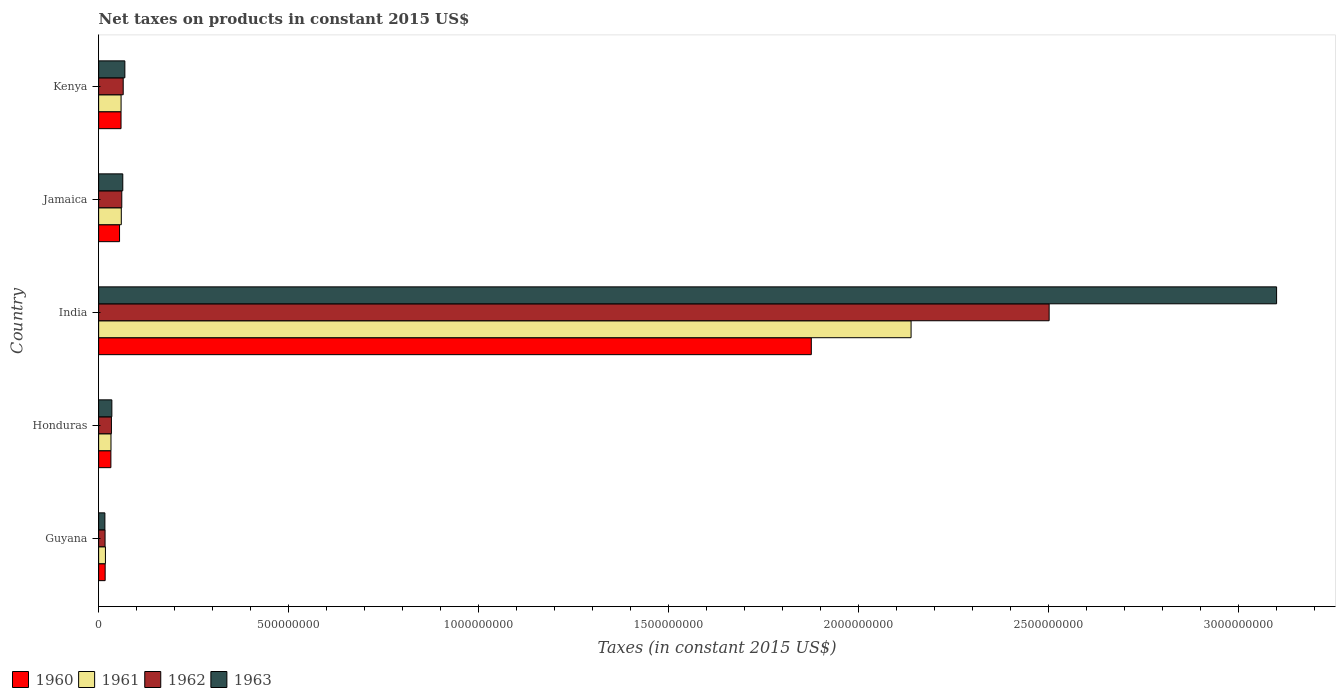How many different coloured bars are there?
Give a very brief answer. 4. Are the number of bars per tick equal to the number of legend labels?
Offer a very short reply. Yes. Are the number of bars on each tick of the Y-axis equal?
Offer a very short reply. Yes. How many bars are there on the 3rd tick from the top?
Ensure brevity in your answer.  4. How many bars are there on the 5th tick from the bottom?
Offer a very short reply. 4. What is the label of the 5th group of bars from the top?
Give a very brief answer. Guyana. What is the net taxes on products in 1963 in India?
Give a very brief answer. 3.10e+09. Across all countries, what is the maximum net taxes on products in 1962?
Your answer should be compact. 2.50e+09. Across all countries, what is the minimum net taxes on products in 1961?
Offer a very short reply. 1.79e+07. In which country was the net taxes on products in 1961 maximum?
Your answer should be very brief. India. In which country was the net taxes on products in 1963 minimum?
Make the answer very short. Guyana. What is the total net taxes on products in 1963 in the graph?
Your response must be concise. 3.28e+09. What is the difference between the net taxes on products in 1961 in India and that in Kenya?
Your answer should be very brief. 2.08e+09. What is the difference between the net taxes on products in 1960 in India and the net taxes on products in 1961 in Honduras?
Provide a short and direct response. 1.84e+09. What is the average net taxes on products in 1960 per country?
Provide a short and direct response. 4.08e+08. What is the difference between the net taxes on products in 1962 and net taxes on products in 1961 in Jamaica?
Your answer should be compact. 1.26e+06. In how many countries, is the net taxes on products in 1962 greater than 2900000000 US$?
Offer a terse response. 0. What is the ratio of the net taxes on products in 1960 in Honduras to that in Kenya?
Provide a succinct answer. 0.55. Is the net taxes on products in 1960 in India less than that in Kenya?
Your response must be concise. No. Is the difference between the net taxes on products in 1962 in India and Kenya greater than the difference between the net taxes on products in 1961 in India and Kenya?
Offer a very short reply. Yes. What is the difference between the highest and the second highest net taxes on products in 1960?
Your answer should be compact. 1.82e+09. What is the difference between the highest and the lowest net taxes on products in 1961?
Offer a terse response. 2.12e+09. In how many countries, is the net taxes on products in 1961 greater than the average net taxes on products in 1961 taken over all countries?
Provide a short and direct response. 1. What does the 1st bar from the top in India represents?
Your answer should be very brief. 1963. What does the 2nd bar from the bottom in Honduras represents?
Make the answer very short. 1961. How many bars are there?
Make the answer very short. 20. Does the graph contain any zero values?
Offer a terse response. No. Does the graph contain grids?
Your answer should be very brief. No. How many legend labels are there?
Ensure brevity in your answer.  4. What is the title of the graph?
Offer a terse response. Net taxes on products in constant 2015 US$. What is the label or title of the X-axis?
Ensure brevity in your answer.  Taxes (in constant 2015 US$). What is the Taxes (in constant 2015 US$) in 1960 in Guyana?
Provide a short and direct response. 1.71e+07. What is the Taxes (in constant 2015 US$) in 1961 in Guyana?
Your response must be concise. 1.79e+07. What is the Taxes (in constant 2015 US$) of 1962 in Guyana?
Make the answer very short. 1.69e+07. What is the Taxes (in constant 2015 US$) of 1963 in Guyana?
Make the answer very short. 1.64e+07. What is the Taxes (in constant 2015 US$) of 1960 in Honduras?
Provide a short and direct response. 3.22e+07. What is the Taxes (in constant 2015 US$) of 1961 in Honduras?
Your answer should be compact. 3.25e+07. What is the Taxes (in constant 2015 US$) in 1962 in Honduras?
Keep it short and to the point. 3.36e+07. What is the Taxes (in constant 2015 US$) of 1963 in Honduras?
Offer a very short reply. 3.48e+07. What is the Taxes (in constant 2015 US$) of 1960 in India?
Keep it short and to the point. 1.88e+09. What is the Taxes (in constant 2015 US$) of 1961 in India?
Provide a short and direct response. 2.14e+09. What is the Taxes (in constant 2015 US$) of 1962 in India?
Your answer should be compact. 2.50e+09. What is the Taxes (in constant 2015 US$) in 1963 in India?
Offer a very short reply. 3.10e+09. What is the Taxes (in constant 2015 US$) in 1960 in Jamaica?
Provide a succinct answer. 5.50e+07. What is the Taxes (in constant 2015 US$) of 1961 in Jamaica?
Keep it short and to the point. 5.96e+07. What is the Taxes (in constant 2015 US$) of 1962 in Jamaica?
Keep it short and to the point. 6.09e+07. What is the Taxes (in constant 2015 US$) of 1963 in Jamaica?
Provide a succinct answer. 6.36e+07. What is the Taxes (in constant 2015 US$) in 1960 in Kenya?
Keep it short and to the point. 5.89e+07. What is the Taxes (in constant 2015 US$) of 1961 in Kenya?
Your response must be concise. 5.91e+07. What is the Taxes (in constant 2015 US$) in 1962 in Kenya?
Offer a very short reply. 6.47e+07. What is the Taxes (in constant 2015 US$) of 1963 in Kenya?
Give a very brief answer. 6.90e+07. Across all countries, what is the maximum Taxes (in constant 2015 US$) of 1960?
Your response must be concise. 1.88e+09. Across all countries, what is the maximum Taxes (in constant 2015 US$) of 1961?
Offer a terse response. 2.14e+09. Across all countries, what is the maximum Taxes (in constant 2015 US$) in 1962?
Your answer should be compact. 2.50e+09. Across all countries, what is the maximum Taxes (in constant 2015 US$) of 1963?
Your answer should be compact. 3.10e+09. Across all countries, what is the minimum Taxes (in constant 2015 US$) of 1960?
Offer a very short reply. 1.71e+07. Across all countries, what is the minimum Taxes (in constant 2015 US$) in 1961?
Your answer should be very brief. 1.79e+07. Across all countries, what is the minimum Taxes (in constant 2015 US$) of 1962?
Make the answer very short. 1.69e+07. Across all countries, what is the minimum Taxes (in constant 2015 US$) in 1963?
Make the answer very short. 1.64e+07. What is the total Taxes (in constant 2015 US$) of 1960 in the graph?
Ensure brevity in your answer.  2.04e+09. What is the total Taxes (in constant 2015 US$) in 1961 in the graph?
Make the answer very short. 2.31e+09. What is the total Taxes (in constant 2015 US$) in 1962 in the graph?
Provide a short and direct response. 2.68e+09. What is the total Taxes (in constant 2015 US$) in 1963 in the graph?
Offer a terse response. 3.28e+09. What is the difference between the Taxes (in constant 2015 US$) of 1960 in Guyana and that in Honduras?
Keep it short and to the point. -1.51e+07. What is the difference between the Taxes (in constant 2015 US$) of 1961 in Guyana and that in Honduras?
Give a very brief answer. -1.46e+07. What is the difference between the Taxes (in constant 2015 US$) in 1962 in Guyana and that in Honduras?
Your response must be concise. -1.67e+07. What is the difference between the Taxes (in constant 2015 US$) of 1963 in Guyana and that in Honduras?
Offer a very short reply. -1.84e+07. What is the difference between the Taxes (in constant 2015 US$) of 1960 in Guyana and that in India?
Your response must be concise. -1.86e+09. What is the difference between the Taxes (in constant 2015 US$) in 1961 in Guyana and that in India?
Provide a succinct answer. -2.12e+09. What is the difference between the Taxes (in constant 2015 US$) of 1962 in Guyana and that in India?
Your answer should be very brief. -2.48e+09. What is the difference between the Taxes (in constant 2015 US$) of 1963 in Guyana and that in India?
Provide a succinct answer. -3.08e+09. What is the difference between the Taxes (in constant 2015 US$) in 1960 in Guyana and that in Jamaica?
Your response must be concise. -3.79e+07. What is the difference between the Taxes (in constant 2015 US$) in 1961 in Guyana and that in Jamaica?
Your answer should be very brief. -4.17e+07. What is the difference between the Taxes (in constant 2015 US$) in 1962 in Guyana and that in Jamaica?
Your answer should be compact. -4.40e+07. What is the difference between the Taxes (in constant 2015 US$) of 1963 in Guyana and that in Jamaica?
Provide a succinct answer. -4.71e+07. What is the difference between the Taxes (in constant 2015 US$) in 1960 in Guyana and that in Kenya?
Give a very brief answer. -4.18e+07. What is the difference between the Taxes (in constant 2015 US$) of 1961 in Guyana and that in Kenya?
Your answer should be compact. -4.12e+07. What is the difference between the Taxes (in constant 2015 US$) in 1962 in Guyana and that in Kenya?
Offer a terse response. -4.77e+07. What is the difference between the Taxes (in constant 2015 US$) of 1963 in Guyana and that in Kenya?
Give a very brief answer. -5.26e+07. What is the difference between the Taxes (in constant 2015 US$) of 1960 in Honduras and that in India?
Ensure brevity in your answer.  -1.84e+09. What is the difference between the Taxes (in constant 2015 US$) in 1961 in Honduras and that in India?
Offer a very short reply. -2.11e+09. What is the difference between the Taxes (in constant 2015 US$) in 1962 in Honduras and that in India?
Your answer should be compact. -2.47e+09. What is the difference between the Taxes (in constant 2015 US$) in 1963 in Honduras and that in India?
Ensure brevity in your answer.  -3.06e+09. What is the difference between the Taxes (in constant 2015 US$) of 1960 in Honduras and that in Jamaica?
Provide a succinct answer. -2.28e+07. What is the difference between the Taxes (in constant 2015 US$) in 1961 in Honduras and that in Jamaica?
Give a very brief answer. -2.71e+07. What is the difference between the Taxes (in constant 2015 US$) in 1962 in Honduras and that in Jamaica?
Make the answer very short. -2.72e+07. What is the difference between the Taxes (in constant 2015 US$) of 1963 in Honduras and that in Jamaica?
Offer a terse response. -2.88e+07. What is the difference between the Taxes (in constant 2015 US$) in 1960 in Honduras and that in Kenya?
Your response must be concise. -2.67e+07. What is the difference between the Taxes (in constant 2015 US$) of 1961 in Honduras and that in Kenya?
Your answer should be compact. -2.66e+07. What is the difference between the Taxes (in constant 2015 US$) of 1962 in Honduras and that in Kenya?
Offer a very short reply. -3.10e+07. What is the difference between the Taxes (in constant 2015 US$) in 1963 in Honduras and that in Kenya?
Keep it short and to the point. -3.42e+07. What is the difference between the Taxes (in constant 2015 US$) of 1960 in India and that in Jamaica?
Provide a succinct answer. 1.82e+09. What is the difference between the Taxes (in constant 2015 US$) of 1961 in India and that in Jamaica?
Provide a succinct answer. 2.08e+09. What is the difference between the Taxes (in constant 2015 US$) in 1962 in India and that in Jamaica?
Offer a terse response. 2.44e+09. What is the difference between the Taxes (in constant 2015 US$) in 1963 in India and that in Jamaica?
Your answer should be compact. 3.04e+09. What is the difference between the Taxes (in constant 2015 US$) of 1960 in India and that in Kenya?
Offer a very short reply. 1.82e+09. What is the difference between the Taxes (in constant 2015 US$) in 1961 in India and that in Kenya?
Your answer should be compact. 2.08e+09. What is the difference between the Taxes (in constant 2015 US$) in 1962 in India and that in Kenya?
Provide a succinct answer. 2.44e+09. What is the difference between the Taxes (in constant 2015 US$) of 1963 in India and that in Kenya?
Keep it short and to the point. 3.03e+09. What is the difference between the Taxes (in constant 2015 US$) of 1960 in Jamaica and that in Kenya?
Offer a very short reply. -3.91e+06. What is the difference between the Taxes (in constant 2015 US$) in 1961 in Jamaica and that in Kenya?
Ensure brevity in your answer.  5.74e+05. What is the difference between the Taxes (in constant 2015 US$) of 1962 in Jamaica and that in Kenya?
Offer a very short reply. -3.75e+06. What is the difference between the Taxes (in constant 2015 US$) in 1963 in Jamaica and that in Kenya?
Provide a succinct answer. -5.46e+06. What is the difference between the Taxes (in constant 2015 US$) in 1960 in Guyana and the Taxes (in constant 2015 US$) in 1961 in Honduras?
Keep it short and to the point. -1.54e+07. What is the difference between the Taxes (in constant 2015 US$) in 1960 in Guyana and the Taxes (in constant 2015 US$) in 1962 in Honduras?
Provide a short and direct response. -1.65e+07. What is the difference between the Taxes (in constant 2015 US$) of 1960 in Guyana and the Taxes (in constant 2015 US$) of 1963 in Honduras?
Your answer should be compact. -1.77e+07. What is the difference between the Taxes (in constant 2015 US$) in 1961 in Guyana and the Taxes (in constant 2015 US$) in 1962 in Honduras?
Provide a succinct answer. -1.57e+07. What is the difference between the Taxes (in constant 2015 US$) of 1961 in Guyana and the Taxes (in constant 2015 US$) of 1963 in Honduras?
Your answer should be compact. -1.69e+07. What is the difference between the Taxes (in constant 2015 US$) in 1962 in Guyana and the Taxes (in constant 2015 US$) in 1963 in Honduras?
Provide a succinct answer. -1.79e+07. What is the difference between the Taxes (in constant 2015 US$) of 1960 in Guyana and the Taxes (in constant 2015 US$) of 1961 in India?
Your response must be concise. -2.12e+09. What is the difference between the Taxes (in constant 2015 US$) in 1960 in Guyana and the Taxes (in constant 2015 US$) in 1962 in India?
Provide a succinct answer. -2.48e+09. What is the difference between the Taxes (in constant 2015 US$) in 1960 in Guyana and the Taxes (in constant 2015 US$) in 1963 in India?
Ensure brevity in your answer.  -3.08e+09. What is the difference between the Taxes (in constant 2015 US$) of 1961 in Guyana and the Taxes (in constant 2015 US$) of 1962 in India?
Keep it short and to the point. -2.48e+09. What is the difference between the Taxes (in constant 2015 US$) of 1961 in Guyana and the Taxes (in constant 2015 US$) of 1963 in India?
Ensure brevity in your answer.  -3.08e+09. What is the difference between the Taxes (in constant 2015 US$) in 1962 in Guyana and the Taxes (in constant 2015 US$) in 1963 in India?
Your answer should be compact. -3.08e+09. What is the difference between the Taxes (in constant 2015 US$) of 1960 in Guyana and the Taxes (in constant 2015 US$) of 1961 in Jamaica?
Ensure brevity in your answer.  -4.25e+07. What is the difference between the Taxes (in constant 2015 US$) of 1960 in Guyana and the Taxes (in constant 2015 US$) of 1962 in Jamaica?
Ensure brevity in your answer.  -4.38e+07. What is the difference between the Taxes (in constant 2015 US$) in 1960 in Guyana and the Taxes (in constant 2015 US$) in 1963 in Jamaica?
Provide a short and direct response. -4.64e+07. What is the difference between the Taxes (in constant 2015 US$) in 1961 in Guyana and the Taxes (in constant 2015 US$) in 1962 in Jamaica?
Ensure brevity in your answer.  -4.30e+07. What is the difference between the Taxes (in constant 2015 US$) of 1961 in Guyana and the Taxes (in constant 2015 US$) of 1963 in Jamaica?
Your answer should be compact. -4.57e+07. What is the difference between the Taxes (in constant 2015 US$) in 1962 in Guyana and the Taxes (in constant 2015 US$) in 1963 in Jamaica?
Your response must be concise. -4.66e+07. What is the difference between the Taxes (in constant 2015 US$) of 1960 in Guyana and the Taxes (in constant 2015 US$) of 1961 in Kenya?
Give a very brief answer. -4.19e+07. What is the difference between the Taxes (in constant 2015 US$) in 1960 in Guyana and the Taxes (in constant 2015 US$) in 1962 in Kenya?
Provide a short and direct response. -4.75e+07. What is the difference between the Taxes (in constant 2015 US$) of 1960 in Guyana and the Taxes (in constant 2015 US$) of 1963 in Kenya?
Give a very brief answer. -5.19e+07. What is the difference between the Taxes (in constant 2015 US$) in 1961 in Guyana and the Taxes (in constant 2015 US$) in 1962 in Kenya?
Offer a terse response. -4.67e+07. What is the difference between the Taxes (in constant 2015 US$) in 1961 in Guyana and the Taxes (in constant 2015 US$) in 1963 in Kenya?
Offer a terse response. -5.11e+07. What is the difference between the Taxes (in constant 2015 US$) in 1962 in Guyana and the Taxes (in constant 2015 US$) in 1963 in Kenya?
Your answer should be compact. -5.21e+07. What is the difference between the Taxes (in constant 2015 US$) of 1960 in Honduras and the Taxes (in constant 2015 US$) of 1961 in India?
Offer a very short reply. -2.11e+09. What is the difference between the Taxes (in constant 2015 US$) in 1960 in Honduras and the Taxes (in constant 2015 US$) in 1962 in India?
Keep it short and to the point. -2.47e+09. What is the difference between the Taxes (in constant 2015 US$) in 1960 in Honduras and the Taxes (in constant 2015 US$) in 1963 in India?
Your answer should be very brief. -3.07e+09. What is the difference between the Taxes (in constant 2015 US$) of 1961 in Honduras and the Taxes (in constant 2015 US$) of 1962 in India?
Keep it short and to the point. -2.47e+09. What is the difference between the Taxes (in constant 2015 US$) of 1961 in Honduras and the Taxes (in constant 2015 US$) of 1963 in India?
Make the answer very short. -3.07e+09. What is the difference between the Taxes (in constant 2015 US$) of 1962 in Honduras and the Taxes (in constant 2015 US$) of 1963 in India?
Offer a very short reply. -3.07e+09. What is the difference between the Taxes (in constant 2015 US$) in 1960 in Honduras and the Taxes (in constant 2015 US$) in 1961 in Jamaica?
Provide a short and direct response. -2.74e+07. What is the difference between the Taxes (in constant 2015 US$) of 1960 in Honduras and the Taxes (in constant 2015 US$) of 1962 in Jamaica?
Offer a very short reply. -2.86e+07. What is the difference between the Taxes (in constant 2015 US$) in 1960 in Honduras and the Taxes (in constant 2015 US$) in 1963 in Jamaica?
Keep it short and to the point. -3.13e+07. What is the difference between the Taxes (in constant 2015 US$) in 1961 in Honduras and the Taxes (in constant 2015 US$) in 1962 in Jamaica?
Your answer should be compact. -2.84e+07. What is the difference between the Taxes (in constant 2015 US$) of 1961 in Honduras and the Taxes (in constant 2015 US$) of 1963 in Jamaica?
Keep it short and to the point. -3.11e+07. What is the difference between the Taxes (in constant 2015 US$) in 1962 in Honduras and the Taxes (in constant 2015 US$) in 1963 in Jamaica?
Make the answer very short. -2.99e+07. What is the difference between the Taxes (in constant 2015 US$) of 1960 in Honduras and the Taxes (in constant 2015 US$) of 1961 in Kenya?
Give a very brief answer. -2.68e+07. What is the difference between the Taxes (in constant 2015 US$) in 1960 in Honduras and the Taxes (in constant 2015 US$) in 1962 in Kenya?
Your answer should be very brief. -3.24e+07. What is the difference between the Taxes (in constant 2015 US$) of 1960 in Honduras and the Taxes (in constant 2015 US$) of 1963 in Kenya?
Keep it short and to the point. -3.68e+07. What is the difference between the Taxes (in constant 2015 US$) in 1961 in Honduras and the Taxes (in constant 2015 US$) in 1962 in Kenya?
Your response must be concise. -3.22e+07. What is the difference between the Taxes (in constant 2015 US$) of 1961 in Honduras and the Taxes (in constant 2015 US$) of 1963 in Kenya?
Offer a terse response. -3.65e+07. What is the difference between the Taxes (in constant 2015 US$) in 1962 in Honduras and the Taxes (in constant 2015 US$) in 1963 in Kenya?
Provide a succinct answer. -3.54e+07. What is the difference between the Taxes (in constant 2015 US$) in 1960 in India and the Taxes (in constant 2015 US$) in 1961 in Jamaica?
Provide a short and direct response. 1.82e+09. What is the difference between the Taxes (in constant 2015 US$) of 1960 in India and the Taxes (in constant 2015 US$) of 1962 in Jamaica?
Your answer should be compact. 1.81e+09. What is the difference between the Taxes (in constant 2015 US$) of 1960 in India and the Taxes (in constant 2015 US$) of 1963 in Jamaica?
Give a very brief answer. 1.81e+09. What is the difference between the Taxes (in constant 2015 US$) in 1961 in India and the Taxes (in constant 2015 US$) in 1962 in Jamaica?
Offer a very short reply. 2.08e+09. What is the difference between the Taxes (in constant 2015 US$) of 1961 in India and the Taxes (in constant 2015 US$) of 1963 in Jamaica?
Give a very brief answer. 2.07e+09. What is the difference between the Taxes (in constant 2015 US$) of 1962 in India and the Taxes (in constant 2015 US$) of 1963 in Jamaica?
Offer a terse response. 2.44e+09. What is the difference between the Taxes (in constant 2015 US$) in 1960 in India and the Taxes (in constant 2015 US$) in 1961 in Kenya?
Make the answer very short. 1.82e+09. What is the difference between the Taxes (in constant 2015 US$) of 1960 in India and the Taxes (in constant 2015 US$) of 1962 in Kenya?
Offer a terse response. 1.81e+09. What is the difference between the Taxes (in constant 2015 US$) in 1960 in India and the Taxes (in constant 2015 US$) in 1963 in Kenya?
Your answer should be compact. 1.81e+09. What is the difference between the Taxes (in constant 2015 US$) of 1961 in India and the Taxes (in constant 2015 US$) of 1962 in Kenya?
Ensure brevity in your answer.  2.07e+09. What is the difference between the Taxes (in constant 2015 US$) in 1961 in India and the Taxes (in constant 2015 US$) in 1963 in Kenya?
Ensure brevity in your answer.  2.07e+09. What is the difference between the Taxes (in constant 2015 US$) in 1962 in India and the Taxes (in constant 2015 US$) in 1963 in Kenya?
Offer a terse response. 2.43e+09. What is the difference between the Taxes (in constant 2015 US$) in 1960 in Jamaica and the Taxes (in constant 2015 US$) in 1961 in Kenya?
Your answer should be compact. -4.05e+06. What is the difference between the Taxes (in constant 2015 US$) in 1960 in Jamaica and the Taxes (in constant 2015 US$) in 1962 in Kenya?
Your answer should be very brief. -9.63e+06. What is the difference between the Taxes (in constant 2015 US$) in 1960 in Jamaica and the Taxes (in constant 2015 US$) in 1963 in Kenya?
Your response must be concise. -1.40e+07. What is the difference between the Taxes (in constant 2015 US$) of 1961 in Jamaica and the Taxes (in constant 2015 US$) of 1962 in Kenya?
Your response must be concise. -5.01e+06. What is the difference between the Taxes (in constant 2015 US$) of 1961 in Jamaica and the Taxes (in constant 2015 US$) of 1963 in Kenya?
Offer a terse response. -9.38e+06. What is the difference between the Taxes (in constant 2015 US$) in 1962 in Jamaica and the Taxes (in constant 2015 US$) in 1963 in Kenya?
Your answer should be compact. -8.12e+06. What is the average Taxes (in constant 2015 US$) in 1960 per country?
Provide a succinct answer. 4.08e+08. What is the average Taxes (in constant 2015 US$) of 1961 per country?
Offer a very short reply. 4.61e+08. What is the average Taxes (in constant 2015 US$) in 1962 per country?
Offer a very short reply. 5.35e+08. What is the average Taxes (in constant 2015 US$) in 1963 per country?
Offer a very short reply. 6.57e+08. What is the difference between the Taxes (in constant 2015 US$) of 1960 and Taxes (in constant 2015 US$) of 1961 in Guyana?
Ensure brevity in your answer.  -7.58e+05. What is the difference between the Taxes (in constant 2015 US$) of 1960 and Taxes (in constant 2015 US$) of 1962 in Guyana?
Your answer should be very brief. 2.33e+05. What is the difference between the Taxes (in constant 2015 US$) of 1960 and Taxes (in constant 2015 US$) of 1963 in Guyana?
Your response must be concise. 7.00e+05. What is the difference between the Taxes (in constant 2015 US$) of 1961 and Taxes (in constant 2015 US$) of 1962 in Guyana?
Make the answer very short. 9.92e+05. What is the difference between the Taxes (in constant 2015 US$) in 1961 and Taxes (in constant 2015 US$) in 1963 in Guyana?
Provide a succinct answer. 1.46e+06. What is the difference between the Taxes (in constant 2015 US$) of 1962 and Taxes (in constant 2015 US$) of 1963 in Guyana?
Offer a terse response. 4.67e+05. What is the difference between the Taxes (in constant 2015 US$) in 1960 and Taxes (in constant 2015 US$) in 1961 in Honduras?
Your answer should be very brief. -2.50e+05. What is the difference between the Taxes (in constant 2015 US$) in 1960 and Taxes (in constant 2015 US$) in 1962 in Honduras?
Offer a very short reply. -1.40e+06. What is the difference between the Taxes (in constant 2015 US$) of 1960 and Taxes (in constant 2015 US$) of 1963 in Honduras?
Offer a terse response. -2.55e+06. What is the difference between the Taxes (in constant 2015 US$) of 1961 and Taxes (in constant 2015 US$) of 1962 in Honduras?
Ensure brevity in your answer.  -1.15e+06. What is the difference between the Taxes (in constant 2015 US$) in 1961 and Taxes (in constant 2015 US$) in 1963 in Honduras?
Give a very brief answer. -2.30e+06. What is the difference between the Taxes (in constant 2015 US$) in 1962 and Taxes (in constant 2015 US$) in 1963 in Honduras?
Your response must be concise. -1.15e+06. What is the difference between the Taxes (in constant 2015 US$) in 1960 and Taxes (in constant 2015 US$) in 1961 in India?
Offer a terse response. -2.63e+08. What is the difference between the Taxes (in constant 2015 US$) in 1960 and Taxes (in constant 2015 US$) in 1962 in India?
Give a very brief answer. -6.26e+08. What is the difference between the Taxes (in constant 2015 US$) in 1960 and Taxes (in constant 2015 US$) in 1963 in India?
Keep it short and to the point. -1.22e+09. What is the difference between the Taxes (in constant 2015 US$) in 1961 and Taxes (in constant 2015 US$) in 1962 in India?
Provide a short and direct response. -3.63e+08. What is the difference between the Taxes (in constant 2015 US$) in 1961 and Taxes (in constant 2015 US$) in 1963 in India?
Provide a succinct answer. -9.62e+08. What is the difference between the Taxes (in constant 2015 US$) of 1962 and Taxes (in constant 2015 US$) of 1963 in India?
Give a very brief answer. -5.99e+08. What is the difference between the Taxes (in constant 2015 US$) of 1960 and Taxes (in constant 2015 US$) of 1961 in Jamaica?
Provide a succinct answer. -4.62e+06. What is the difference between the Taxes (in constant 2015 US$) of 1960 and Taxes (in constant 2015 US$) of 1962 in Jamaica?
Your answer should be very brief. -5.88e+06. What is the difference between the Taxes (in constant 2015 US$) in 1960 and Taxes (in constant 2015 US$) in 1963 in Jamaica?
Your answer should be compact. -8.54e+06. What is the difference between the Taxes (in constant 2015 US$) of 1961 and Taxes (in constant 2015 US$) of 1962 in Jamaica?
Provide a short and direct response. -1.26e+06. What is the difference between the Taxes (in constant 2015 US$) of 1961 and Taxes (in constant 2015 US$) of 1963 in Jamaica?
Your response must be concise. -3.92e+06. What is the difference between the Taxes (in constant 2015 US$) of 1962 and Taxes (in constant 2015 US$) of 1963 in Jamaica?
Offer a very short reply. -2.66e+06. What is the difference between the Taxes (in constant 2015 US$) of 1960 and Taxes (in constant 2015 US$) of 1961 in Kenya?
Your answer should be compact. -1.40e+05. What is the difference between the Taxes (in constant 2015 US$) of 1960 and Taxes (in constant 2015 US$) of 1962 in Kenya?
Offer a very short reply. -5.73e+06. What is the difference between the Taxes (in constant 2015 US$) in 1960 and Taxes (in constant 2015 US$) in 1963 in Kenya?
Offer a terse response. -1.01e+07. What is the difference between the Taxes (in constant 2015 US$) in 1961 and Taxes (in constant 2015 US$) in 1962 in Kenya?
Keep it short and to the point. -5.59e+06. What is the difference between the Taxes (in constant 2015 US$) in 1961 and Taxes (in constant 2015 US$) in 1963 in Kenya?
Give a very brief answer. -9.95e+06. What is the difference between the Taxes (in constant 2015 US$) in 1962 and Taxes (in constant 2015 US$) in 1963 in Kenya?
Give a very brief answer. -4.37e+06. What is the ratio of the Taxes (in constant 2015 US$) in 1960 in Guyana to that in Honduras?
Give a very brief answer. 0.53. What is the ratio of the Taxes (in constant 2015 US$) of 1961 in Guyana to that in Honduras?
Give a very brief answer. 0.55. What is the ratio of the Taxes (in constant 2015 US$) of 1962 in Guyana to that in Honduras?
Make the answer very short. 0.5. What is the ratio of the Taxes (in constant 2015 US$) in 1963 in Guyana to that in Honduras?
Ensure brevity in your answer.  0.47. What is the ratio of the Taxes (in constant 2015 US$) of 1960 in Guyana to that in India?
Offer a terse response. 0.01. What is the ratio of the Taxes (in constant 2015 US$) in 1961 in Guyana to that in India?
Your answer should be very brief. 0.01. What is the ratio of the Taxes (in constant 2015 US$) in 1962 in Guyana to that in India?
Offer a very short reply. 0.01. What is the ratio of the Taxes (in constant 2015 US$) in 1963 in Guyana to that in India?
Your answer should be very brief. 0.01. What is the ratio of the Taxes (in constant 2015 US$) in 1960 in Guyana to that in Jamaica?
Keep it short and to the point. 0.31. What is the ratio of the Taxes (in constant 2015 US$) in 1961 in Guyana to that in Jamaica?
Give a very brief answer. 0.3. What is the ratio of the Taxes (in constant 2015 US$) in 1962 in Guyana to that in Jamaica?
Offer a terse response. 0.28. What is the ratio of the Taxes (in constant 2015 US$) in 1963 in Guyana to that in Jamaica?
Provide a short and direct response. 0.26. What is the ratio of the Taxes (in constant 2015 US$) in 1960 in Guyana to that in Kenya?
Your answer should be compact. 0.29. What is the ratio of the Taxes (in constant 2015 US$) in 1961 in Guyana to that in Kenya?
Make the answer very short. 0.3. What is the ratio of the Taxes (in constant 2015 US$) of 1962 in Guyana to that in Kenya?
Provide a succinct answer. 0.26. What is the ratio of the Taxes (in constant 2015 US$) of 1963 in Guyana to that in Kenya?
Your answer should be compact. 0.24. What is the ratio of the Taxes (in constant 2015 US$) of 1960 in Honduras to that in India?
Your response must be concise. 0.02. What is the ratio of the Taxes (in constant 2015 US$) in 1961 in Honduras to that in India?
Make the answer very short. 0.02. What is the ratio of the Taxes (in constant 2015 US$) in 1962 in Honduras to that in India?
Provide a succinct answer. 0.01. What is the ratio of the Taxes (in constant 2015 US$) in 1963 in Honduras to that in India?
Make the answer very short. 0.01. What is the ratio of the Taxes (in constant 2015 US$) of 1960 in Honduras to that in Jamaica?
Ensure brevity in your answer.  0.59. What is the ratio of the Taxes (in constant 2015 US$) of 1961 in Honduras to that in Jamaica?
Offer a very short reply. 0.54. What is the ratio of the Taxes (in constant 2015 US$) in 1962 in Honduras to that in Jamaica?
Your answer should be very brief. 0.55. What is the ratio of the Taxes (in constant 2015 US$) in 1963 in Honduras to that in Jamaica?
Provide a short and direct response. 0.55. What is the ratio of the Taxes (in constant 2015 US$) in 1960 in Honduras to that in Kenya?
Give a very brief answer. 0.55. What is the ratio of the Taxes (in constant 2015 US$) of 1961 in Honduras to that in Kenya?
Your answer should be compact. 0.55. What is the ratio of the Taxes (in constant 2015 US$) in 1962 in Honduras to that in Kenya?
Ensure brevity in your answer.  0.52. What is the ratio of the Taxes (in constant 2015 US$) in 1963 in Honduras to that in Kenya?
Keep it short and to the point. 0.5. What is the ratio of the Taxes (in constant 2015 US$) in 1960 in India to that in Jamaica?
Offer a very short reply. 34.08. What is the ratio of the Taxes (in constant 2015 US$) in 1961 in India to that in Jamaica?
Make the answer very short. 35.85. What is the ratio of the Taxes (in constant 2015 US$) in 1962 in India to that in Jamaica?
Provide a short and direct response. 41.07. What is the ratio of the Taxes (in constant 2015 US$) of 1963 in India to that in Jamaica?
Provide a short and direct response. 48.77. What is the ratio of the Taxes (in constant 2015 US$) in 1960 in India to that in Kenya?
Offer a very short reply. 31.82. What is the ratio of the Taxes (in constant 2015 US$) of 1961 in India to that in Kenya?
Provide a short and direct response. 36.19. What is the ratio of the Taxes (in constant 2015 US$) of 1962 in India to that in Kenya?
Your answer should be compact. 38.69. What is the ratio of the Taxes (in constant 2015 US$) in 1963 in India to that in Kenya?
Your response must be concise. 44.91. What is the ratio of the Taxes (in constant 2015 US$) in 1960 in Jamaica to that in Kenya?
Offer a very short reply. 0.93. What is the ratio of the Taxes (in constant 2015 US$) of 1961 in Jamaica to that in Kenya?
Keep it short and to the point. 1.01. What is the ratio of the Taxes (in constant 2015 US$) of 1962 in Jamaica to that in Kenya?
Your answer should be compact. 0.94. What is the ratio of the Taxes (in constant 2015 US$) in 1963 in Jamaica to that in Kenya?
Give a very brief answer. 0.92. What is the difference between the highest and the second highest Taxes (in constant 2015 US$) in 1960?
Your response must be concise. 1.82e+09. What is the difference between the highest and the second highest Taxes (in constant 2015 US$) in 1961?
Your answer should be very brief. 2.08e+09. What is the difference between the highest and the second highest Taxes (in constant 2015 US$) of 1962?
Your answer should be compact. 2.44e+09. What is the difference between the highest and the second highest Taxes (in constant 2015 US$) in 1963?
Your answer should be very brief. 3.03e+09. What is the difference between the highest and the lowest Taxes (in constant 2015 US$) of 1960?
Offer a very short reply. 1.86e+09. What is the difference between the highest and the lowest Taxes (in constant 2015 US$) of 1961?
Ensure brevity in your answer.  2.12e+09. What is the difference between the highest and the lowest Taxes (in constant 2015 US$) in 1962?
Offer a terse response. 2.48e+09. What is the difference between the highest and the lowest Taxes (in constant 2015 US$) in 1963?
Give a very brief answer. 3.08e+09. 